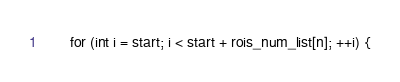Convert code to text. <code><loc_0><loc_0><loc_500><loc_500><_Cuda_>      for (int i = start; i < start + rois_num_list[n]; ++i) {</code> 